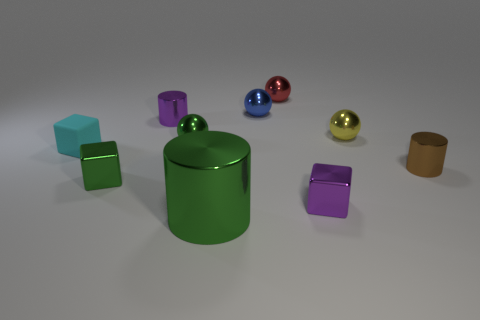Subtract all green balls. How many balls are left? 3 Subtract all green balls. How many balls are left? 3 Subtract 1 cylinders. How many cylinders are left? 2 Subtract all cylinders. How many objects are left? 7 Subtract all gray cylinders. Subtract all yellow spheres. How many cylinders are left? 3 Add 8 tiny metallic cylinders. How many tiny metallic cylinders exist? 10 Subtract 0 cyan cylinders. How many objects are left? 10 Subtract all small green objects. Subtract all big green matte blocks. How many objects are left? 8 Add 3 red metallic balls. How many red metallic balls are left? 4 